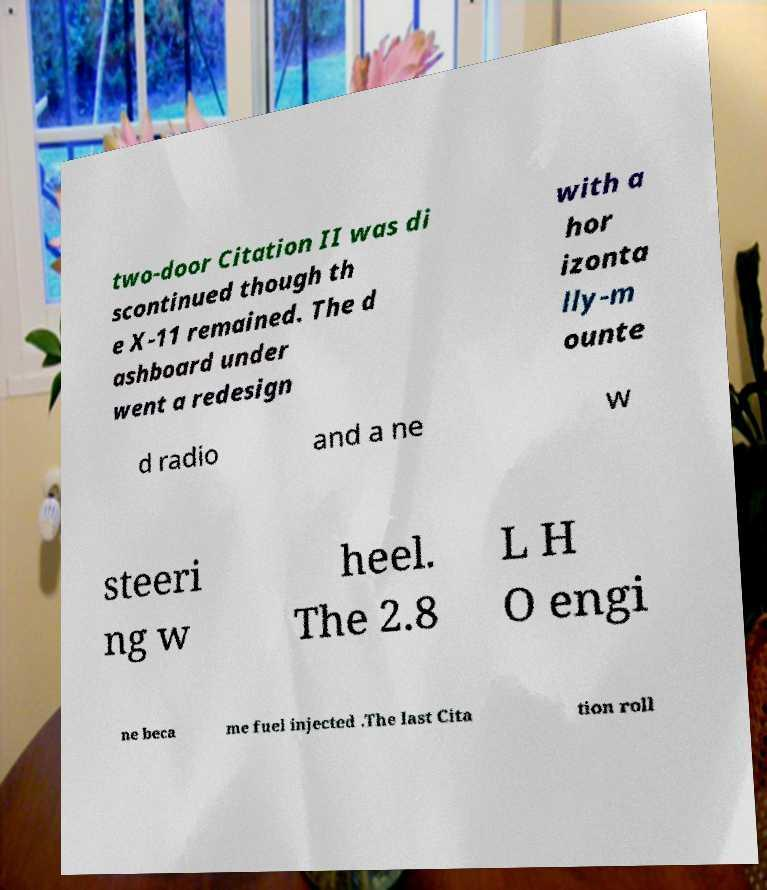Could you extract and type out the text from this image? two-door Citation II was di scontinued though th e X-11 remained. The d ashboard under went a redesign with a hor izonta lly-m ounte d radio and a ne w steeri ng w heel. The 2.8 L H O engi ne beca me fuel injected .The last Cita tion roll 